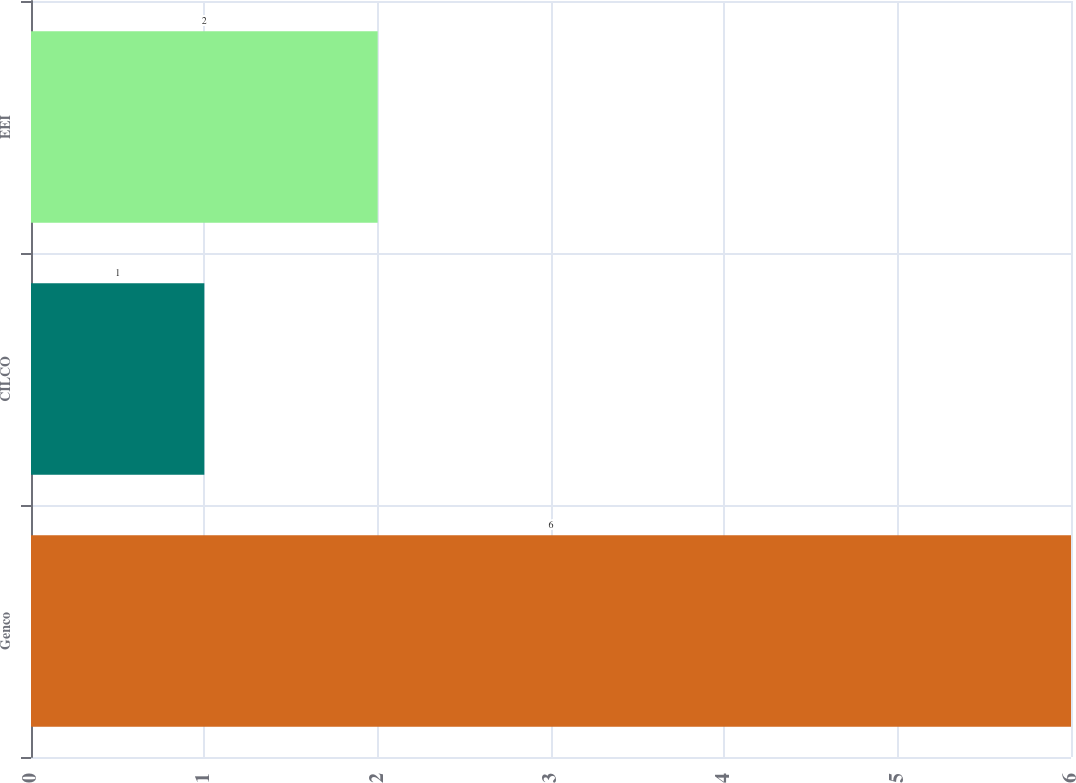Convert chart. <chart><loc_0><loc_0><loc_500><loc_500><bar_chart><fcel>Genco<fcel>CILCO<fcel>EEI<nl><fcel>6<fcel>1<fcel>2<nl></chart> 